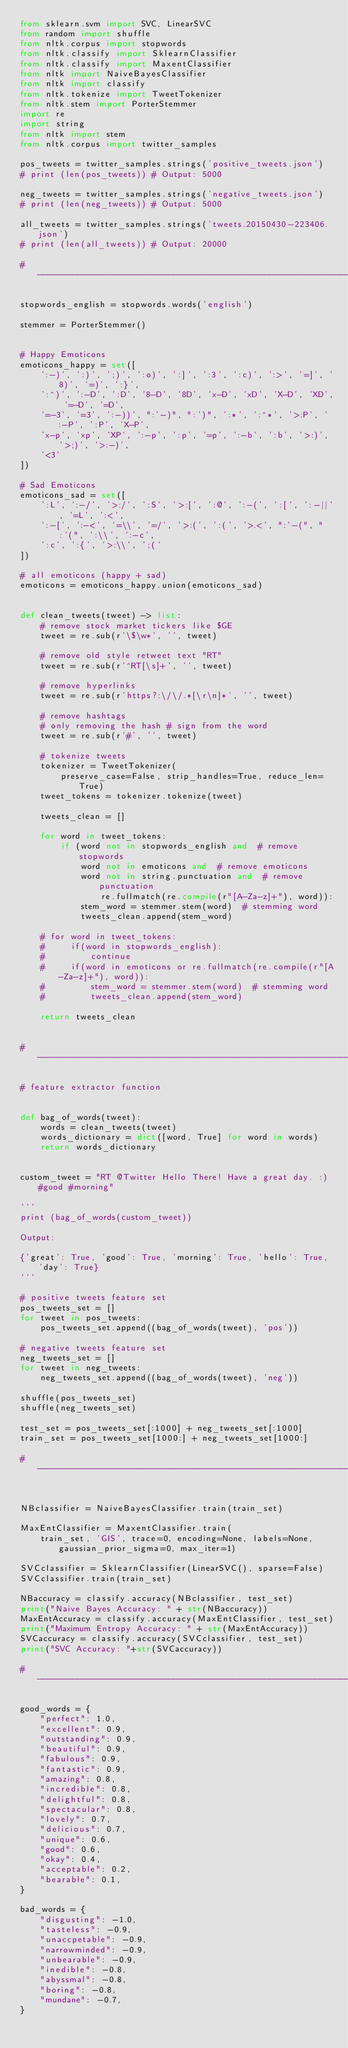<code> <loc_0><loc_0><loc_500><loc_500><_Python_>from sklearn.svm import SVC, LinearSVC
from random import shuffle
from nltk.corpus import stopwords
from nltk.classify import SklearnClassifier
from nltk.classify import MaxentClassifier
from nltk import NaiveBayesClassifier
from nltk import classify
from nltk.tokenize import TweetTokenizer
from nltk.stem import PorterStemmer
import re
import string
from nltk import stem
from nltk.corpus import twitter_samples

pos_tweets = twitter_samples.strings('positive_tweets.json')
# print (len(pos_tweets)) # Output: 5000

neg_tweets = twitter_samples.strings('negative_tweets.json')
# print (len(neg_tweets)) # Output: 5000

all_tweets = twitter_samples.strings('tweets.20150430-223406.json')
# print (len(all_tweets)) # Output: 20000

#---------------------------------------------------------------------#

stopwords_english = stopwords.words('english')

stemmer = PorterStemmer()


# Happy Emoticons
emoticons_happy = set([
    ':-)', ':)', ';)', ':o)', ':]', ':3', ':c)', ':>', '=]', '8)', '=)', ':}',
    ':^)', ':-D', ':D', '8-D', '8D', 'x-D', 'xD', 'X-D', 'XD', '=-D', '=D',
    '=-3', '=3', ':-))', ":'-)", ":')", ':*', ':^*', '>:P', ':-P', ':P', 'X-P',
    'x-p', 'xp', 'XP', ':-p', ':p', '=p', ':-b', ':b', '>:)', '>;)', '>:-)',
    '<3'
])

# Sad Emoticons
emoticons_sad = set([
    ':L', ':-/', '>:/', ':S', '>:[', ':@', ':-(', ':[', ':-||', '=L', ':<',
    ':-[', ':-<', '=\\', '=/', '>:(', ':(', '>.<', ":'-(", ":'(", ':\\', ':-c',
    ':c', ':{', '>:\\', ';('
])

# all emoticons (happy + sad)
emoticons = emoticons_happy.union(emoticons_sad)


def clean_tweets(tweet) -> list:
    # remove stock market tickers like $GE
    tweet = re.sub(r'\$\w*', '', tweet)

    # remove old style retweet text "RT"
    tweet = re.sub(r'^RT[\s]+', '', tweet)

    # remove hyperlinks
    tweet = re.sub(r'https?:\/\/.*[\r\n]*', '', tweet)

    # remove hashtags
    # only removing the hash # sign from the word
    tweet = re.sub(r'#', '', tweet)

    # tokenize tweets
    tokenizer = TweetTokenizer(
        preserve_case=False, strip_handles=True, reduce_len=True)
    tweet_tokens = tokenizer.tokenize(tweet)

    tweets_clean = []

    for word in tweet_tokens:
        if (word not in stopwords_english and  # remove stopwords
            word not in emoticons and  # remove emoticons
            word not in string.punctuation and  # remove punctuation
                re.fullmatch(re.compile(r"[A-Za-z]+"), word)): 
            stem_word = stemmer.stem(word)  # stemming word
            tweets_clean.append(stem_word)

    # for word in tweet_tokens:
    #     if(word in stopwords_english):
    #         continue
    #     if(word in emoticons or re.fullmatch(re.compile(r"[A-Za-z]+"), word)):
    #         stem_word = stemmer.stem(word)  # stemming word
    #         tweets_clean.append(stem_word)

    return tweets_clean


#---------------------------------------------------------------------#

# feature extractor function


def bag_of_words(tweet):
    words = clean_tweets(tweet)
    words_dictionary = dict([word, True] for word in words)
    return words_dictionary


custom_tweet = "RT @Twitter Hello There! Have a great day. :) #good #morning"

'''
print (bag_of_words(custom_tweet))

Output:
 
{'great': True, 'good': True, 'morning': True, 'hello': True, 'day': True}
'''

# positive tweets feature set
pos_tweets_set = []
for tweet in pos_tweets:
    pos_tweets_set.append((bag_of_words(tweet), 'pos'))

# negative tweets feature set
neg_tweets_set = []
for tweet in neg_tweets:
    neg_tweets_set.append((bag_of_words(tweet), 'neg'))

shuffle(pos_tweets_set)
shuffle(neg_tweets_set)

test_set = pos_tweets_set[:1000] + neg_tweets_set[:1000]
train_set = pos_tweets_set[1000:] + neg_tweets_set[1000:]

#---------------------------------------------------------------------#


NBclassifier = NaiveBayesClassifier.train(train_set)

MaxEntClassifier = MaxentClassifier.train(
    train_set, 'GIS', trace=0, encoding=None, labels=None, gaussian_prior_sigma=0, max_iter=1)

SVCclassifier = SklearnClassifier(LinearSVC(), sparse=False)
SVCclassifier.train(train_set)

NBaccuracy = classify.accuracy(NBclassifier, test_set)
print("Naive Bayes Accuracy: " + str(NBaccuracy))
MaxEntAccuracy = classify.accuracy(MaxEntClassifier, test_set)
print("Maximum Entropy Accuracy: " + str(MaxEntAccuracy))
SVCaccuracy = classify.accuracy(SVCclassifier, test_set)
print("SVC Accuracy: "+str(SVCaccuracy))

#---------------------------------------------------------------------#

good_words = {
    "perfect": 1.0,
    "excellent": 0.9,
    "outstanding": 0.9,
    "beautiful": 0.9,
    "fabulous": 0.9,
    "fantastic": 0.9,
    "amazing": 0.8,
    "incredible": 0.8,
    "delightful": 0.8,
    "spectacular": 0.8,
    "lovely": 0.7,
    "delicious": 0.7,
    "unique": 0.6,
    "good": 0.6,
    "okay": 0.4,
    "acceptable": 0.2,
    "bearable": 0.1,
}

bad_words = {
    "disgusting": -1.0,
    "tasteless": -0.9,
    "unaccpetable": -0.9,
    "narrowminded": -0.9,
    "unbearable": -0.9,
    "inedible": -0.8,
    "abyssmal": -0.8,
    "boring": -0.8,
    "mundane": -0.7,
}

</code> 